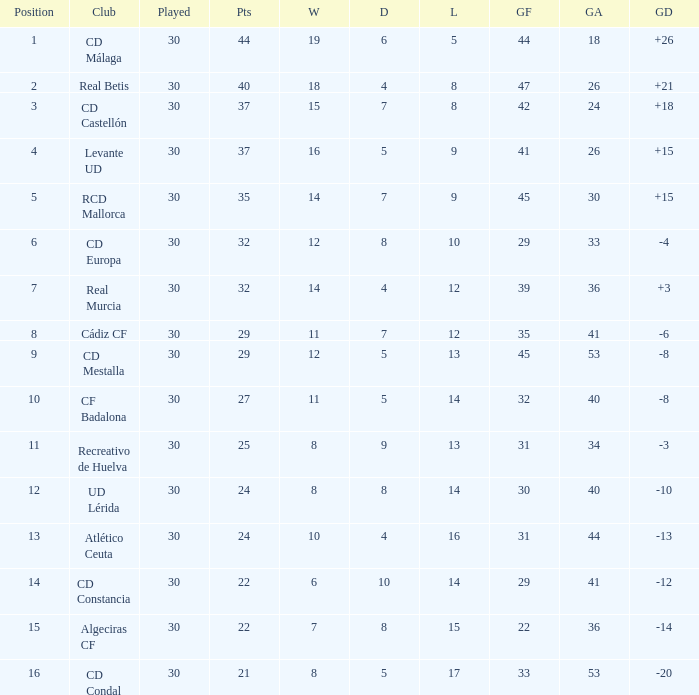Would you be able to parse every entry in this table? {'header': ['Position', 'Club', 'Played', 'Pts', 'W', 'D', 'L', 'GF', 'GA', 'GD'], 'rows': [['1', 'CD Málaga', '30', '44', '19', '6', '5', '44', '18', '+26'], ['2', 'Real Betis', '30', '40', '18', '4', '8', '47', '26', '+21'], ['3', 'CD Castellón', '30', '37', '15', '7', '8', '42', '24', '+18'], ['4', 'Levante UD', '30', '37', '16', '5', '9', '41', '26', '+15'], ['5', 'RCD Mallorca', '30', '35', '14', '7', '9', '45', '30', '+15'], ['6', 'CD Europa', '30', '32', '12', '8', '10', '29', '33', '-4'], ['7', 'Real Murcia', '30', '32', '14', '4', '12', '39', '36', '+3'], ['8', 'Cádiz CF', '30', '29', '11', '7', '12', '35', '41', '-6'], ['9', 'CD Mestalla', '30', '29', '12', '5', '13', '45', '53', '-8'], ['10', 'CF Badalona', '30', '27', '11', '5', '14', '32', '40', '-8'], ['11', 'Recreativo de Huelva', '30', '25', '8', '9', '13', '31', '34', '-3'], ['12', 'UD Lérida', '30', '24', '8', '8', '14', '30', '40', '-10'], ['13', 'Atlético Ceuta', '30', '24', '10', '4', '16', '31', '44', '-13'], ['14', 'CD Constancia', '30', '22', '6', '10', '14', '29', '41', '-12'], ['15', 'Algeciras CF', '30', '22', '7', '8', '15', '22', '36', '-14'], ['16', 'CD Condal', '30', '21', '8', '5', '17', '33', '53', '-20']]} What is the losses when the goal difference is larger than 26? None. 